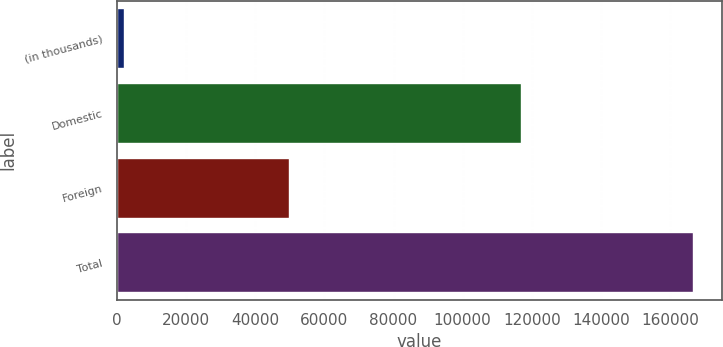<chart> <loc_0><loc_0><loc_500><loc_500><bar_chart><fcel>(in thousands)<fcel>Domestic<fcel>Foreign<fcel>Total<nl><fcel>2008<fcel>116786<fcel>49905<fcel>166691<nl></chart> 